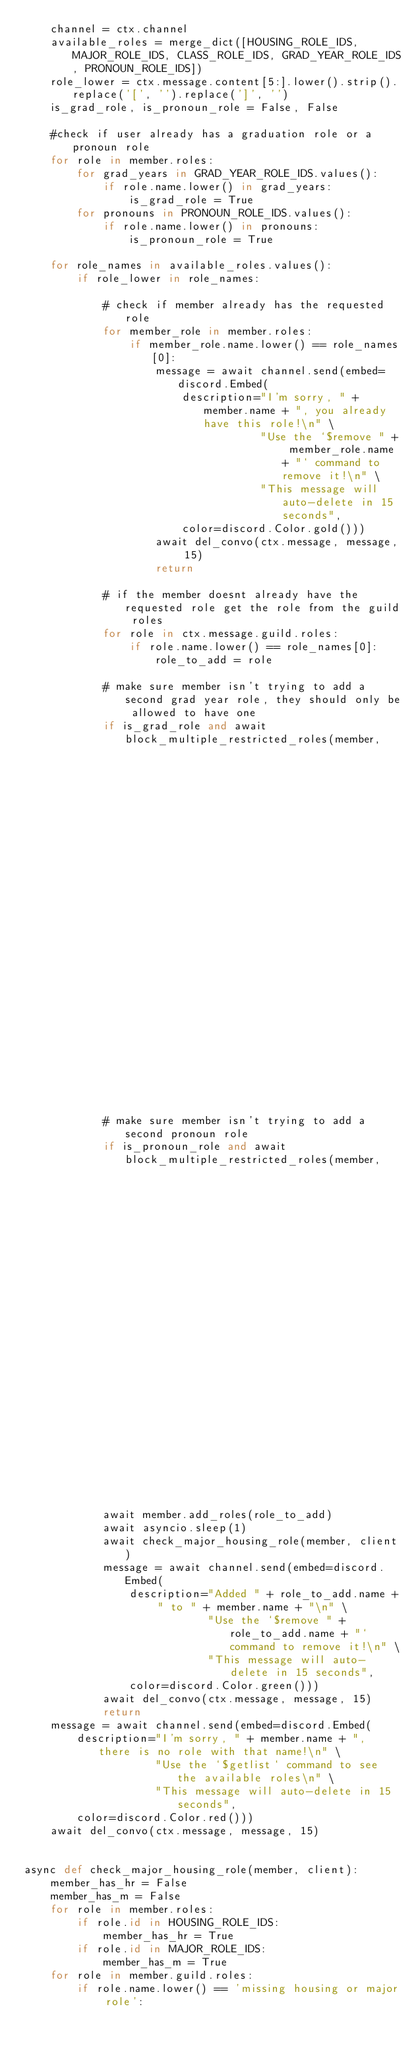Convert code to text. <code><loc_0><loc_0><loc_500><loc_500><_Python_>    channel = ctx.channel
    available_roles = merge_dict([HOUSING_ROLE_IDS, MAJOR_ROLE_IDS, CLASS_ROLE_IDS, GRAD_YEAR_ROLE_IDS, PRONOUN_ROLE_IDS])
    role_lower = ctx.message.content[5:].lower().strip().replace('[', '').replace(']', '')
    is_grad_role, is_pronoun_role = False, False

    #check if user already has a graduation role or a pronoun role
    for role in member.roles:
        for grad_years in GRAD_YEAR_ROLE_IDS.values():
            if role.name.lower() in grad_years:
                is_grad_role = True
        for pronouns in PRONOUN_ROLE_IDS.values():
            if role.name.lower() in pronouns:
                is_pronoun_role = True

    for role_names in available_roles.values():
        if role_lower in role_names:

            # check if member already has the requested role
            for member_role in member.roles:
                if member_role.name.lower() == role_names[0]:
                    message = await channel.send(embed=discord.Embed(
                        description="I'm sorry, " + member.name + ", you already have this role!\n" \
                                    "Use the `$remove " + member_role.name + "` command to remove it!\n" \
                                    "This message will auto-delete in 15 seconds",
                        color=discord.Color.gold()))
                    await del_convo(ctx.message, message, 15)
                    return

            # if the member doesnt already have the requested role get the role from the guild roles
            for role in ctx.message.guild.roles:
                if role.name.lower() == role_names[0]:
                    role_to_add = role
                    
            # make sure member isn't trying to add a second grad year role, they should only be allowed to have one
            if is_grad_role and await block_multiple_restricted_roles(member, 
                                                                      channel,
                                                                      ctx,
                                                                      GRAD_YEAR_ROLE_IDS,
                                                                      role_to_add.name.lower(),
                                                                      'graduation year'): return
            
            # make sure member isn't trying to add a second pronoun role
            if is_pronoun_role and await block_multiple_restricted_roles(member, 
                                                                         channel,
                                                                         ctx,
                                                                         PRONOUN_ROLE_IDS,
                                                                         role_to_add.name.lower(),
                                                                         'pronoun'): return 

            await member.add_roles(role_to_add)
            await asyncio.sleep(1)
            await check_major_housing_role(member, client)
            message = await channel.send(embed=discord.Embed(
                description="Added " + role_to_add.name + " to " + member.name + "\n" \
                            "Use the `$remove " + role_to_add.name + "` command to remove it!\n" \
                            "This message will auto-delete in 15 seconds", 
                color=discord.Color.green()))
            await del_convo(ctx.message, message, 15)
            return
    message = await channel.send(embed=discord.Embed(
        description="I'm sorry, " + member.name + ", there is no role with that name!\n" \
                    "Use the `$getlist` command to see the available roles\n" \
                    "This message will auto-delete in 15 seconds",
        color=discord.Color.red()))
    await del_convo(ctx.message, message, 15)


async def check_major_housing_role(member, client):
    member_has_hr = False
    member_has_m = False
    for role in member.roles:
        if role.id in HOUSING_ROLE_IDS:
            member_has_hr = True
        if role.id in MAJOR_ROLE_IDS:
            member_has_m = True
    for role in member.guild.roles:
        if role.name.lower() == 'missing housing or major role':</code> 